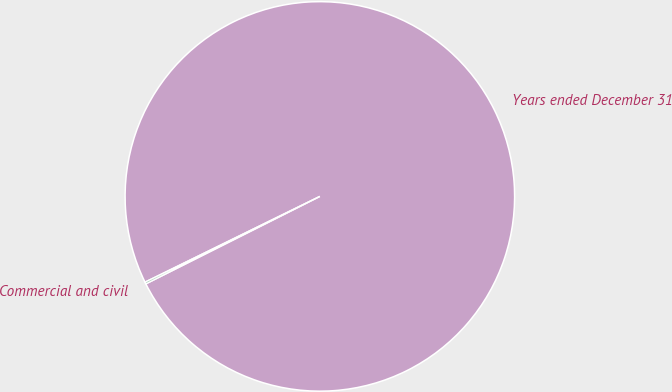<chart> <loc_0><loc_0><loc_500><loc_500><pie_chart><fcel>Years ended December 31<fcel>Commercial and civil<nl><fcel>99.85%<fcel>0.15%<nl></chart> 